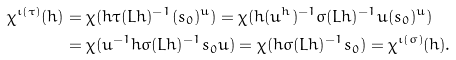<formula> <loc_0><loc_0><loc_500><loc_500>\chi ^ { \iota ( \tau ) } ( h ) & = \chi ( h \tau ( L h ) ^ { - 1 } ( s _ { 0 } ) ^ { u } ) = \chi ( h ( u ^ { h } ) ^ { - 1 } \sigma ( L h ) ^ { - 1 } u ( s _ { 0 } ) ^ { u } ) \\ & = \chi ( u ^ { - 1 } h \sigma ( L h ) ^ { - 1 } s _ { 0 } u ) = \chi ( h \sigma ( L h ) ^ { - 1 } s _ { 0 } ) = \chi ^ { \iota ( \sigma ) } ( h ) .</formula> 